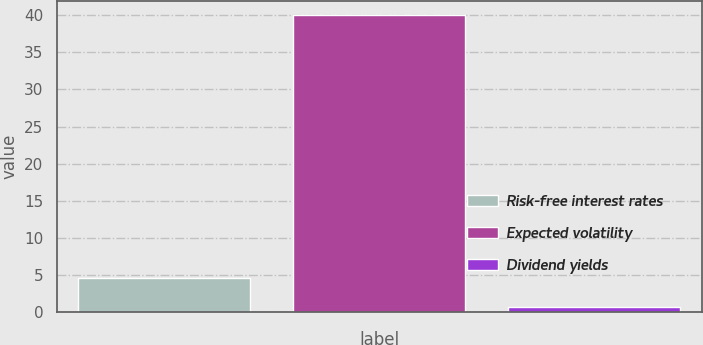<chart> <loc_0><loc_0><loc_500><loc_500><bar_chart><fcel>Risk-free interest rates<fcel>Expected volatility<fcel>Dividend yields<nl><fcel>4.54<fcel>40<fcel>0.6<nl></chart> 